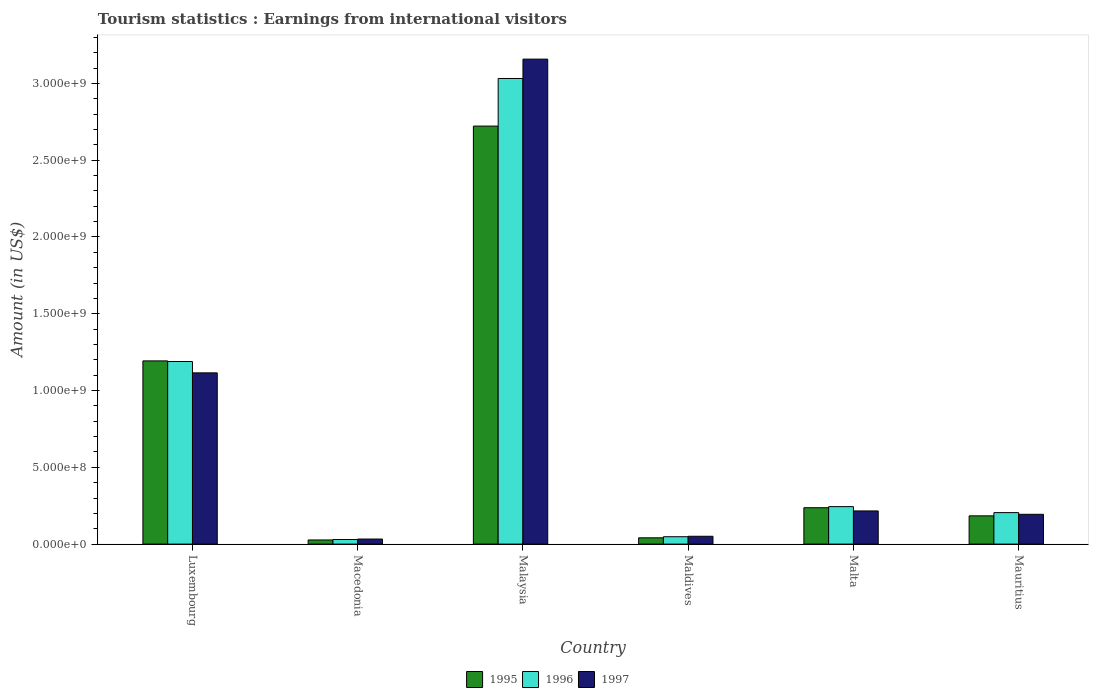How many different coloured bars are there?
Keep it short and to the point. 3. Are the number of bars on each tick of the X-axis equal?
Your response must be concise. Yes. What is the label of the 6th group of bars from the left?
Provide a succinct answer. Mauritius. In how many cases, is the number of bars for a given country not equal to the number of legend labels?
Your response must be concise. 0. What is the earnings from international visitors in 1995 in Malaysia?
Give a very brief answer. 2.72e+09. Across all countries, what is the maximum earnings from international visitors in 1996?
Provide a succinct answer. 3.03e+09. Across all countries, what is the minimum earnings from international visitors in 1995?
Your answer should be very brief. 2.70e+07. In which country was the earnings from international visitors in 1997 maximum?
Your answer should be very brief. Malaysia. In which country was the earnings from international visitors in 1995 minimum?
Provide a succinct answer. Macedonia. What is the total earnings from international visitors in 1995 in the graph?
Provide a succinct answer. 4.40e+09. What is the difference between the earnings from international visitors in 1995 in Macedonia and that in Mauritius?
Your answer should be very brief. -1.57e+08. What is the difference between the earnings from international visitors in 1995 in Luxembourg and the earnings from international visitors in 1997 in Malta?
Your response must be concise. 9.77e+08. What is the average earnings from international visitors in 1997 per country?
Keep it short and to the point. 7.94e+08. What is the difference between the earnings from international visitors of/in 1996 and earnings from international visitors of/in 1997 in Luxembourg?
Provide a succinct answer. 7.40e+07. In how many countries, is the earnings from international visitors in 1997 greater than 1400000000 US$?
Give a very brief answer. 1. What is the ratio of the earnings from international visitors in 1996 in Malaysia to that in Mauritius?
Make the answer very short. 14.79. Is the difference between the earnings from international visitors in 1996 in Luxembourg and Mauritius greater than the difference between the earnings from international visitors in 1997 in Luxembourg and Mauritius?
Offer a very short reply. Yes. What is the difference between the highest and the second highest earnings from international visitors in 1996?
Make the answer very short. 2.79e+09. What is the difference between the highest and the lowest earnings from international visitors in 1997?
Your answer should be compact. 3.12e+09. Is the sum of the earnings from international visitors in 1996 in Macedonia and Maldives greater than the maximum earnings from international visitors in 1995 across all countries?
Provide a short and direct response. No. What does the 3rd bar from the left in Malta represents?
Offer a very short reply. 1997. Are all the bars in the graph horizontal?
Provide a succinct answer. No. Are the values on the major ticks of Y-axis written in scientific E-notation?
Your answer should be compact. Yes. Does the graph contain any zero values?
Provide a succinct answer. No. What is the title of the graph?
Your answer should be very brief. Tourism statistics : Earnings from international visitors. What is the Amount (in US$) of 1995 in Luxembourg?
Ensure brevity in your answer.  1.19e+09. What is the Amount (in US$) of 1996 in Luxembourg?
Offer a very short reply. 1.19e+09. What is the Amount (in US$) in 1997 in Luxembourg?
Provide a short and direct response. 1.12e+09. What is the Amount (in US$) in 1995 in Macedonia?
Keep it short and to the point. 2.70e+07. What is the Amount (in US$) in 1996 in Macedonia?
Provide a short and direct response. 3.00e+07. What is the Amount (in US$) of 1997 in Macedonia?
Give a very brief answer. 3.30e+07. What is the Amount (in US$) in 1995 in Malaysia?
Offer a terse response. 2.72e+09. What is the Amount (in US$) of 1996 in Malaysia?
Provide a short and direct response. 3.03e+09. What is the Amount (in US$) in 1997 in Malaysia?
Ensure brevity in your answer.  3.16e+09. What is the Amount (in US$) in 1995 in Maldives?
Provide a short and direct response. 4.10e+07. What is the Amount (in US$) in 1996 in Maldives?
Your response must be concise. 4.80e+07. What is the Amount (in US$) of 1997 in Maldives?
Keep it short and to the point. 5.10e+07. What is the Amount (in US$) of 1995 in Malta?
Provide a succinct answer. 2.37e+08. What is the Amount (in US$) in 1996 in Malta?
Your answer should be compact. 2.44e+08. What is the Amount (in US$) of 1997 in Malta?
Ensure brevity in your answer.  2.16e+08. What is the Amount (in US$) of 1995 in Mauritius?
Ensure brevity in your answer.  1.84e+08. What is the Amount (in US$) in 1996 in Mauritius?
Ensure brevity in your answer.  2.05e+08. What is the Amount (in US$) in 1997 in Mauritius?
Offer a very short reply. 1.94e+08. Across all countries, what is the maximum Amount (in US$) in 1995?
Provide a succinct answer. 2.72e+09. Across all countries, what is the maximum Amount (in US$) in 1996?
Provide a succinct answer. 3.03e+09. Across all countries, what is the maximum Amount (in US$) of 1997?
Your answer should be very brief. 3.16e+09. Across all countries, what is the minimum Amount (in US$) of 1995?
Offer a very short reply. 2.70e+07. Across all countries, what is the minimum Amount (in US$) of 1996?
Offer a very short reply. 3.00e+07. Across all countries, what is the minimum Amount (in US$) of 1997?
Offer a very short reply. 3.30e+07. What is the total Amount (in US$) in 1995 in the graph?
Your answer should be very brief. 4.40e+09. What is the total Amount (in US$) in 1996 in the graph?
Offer a very short reply. 4.75e+09. What is the total Amount (in US$) in 1997 in the graph?
Your answer should be very brief. 4.77e+09. What is the difference between the Amount (in US$) of 1995 in Luxembourg and that in Macedonia?
Offer a very short reply. 1.17e+09. What is the difference between the Amount (in US$) of 1996 in Luxembourg and that in Macedonia?
Provide a short and direct response. 1.16e+09. What is the difference between the Amount (in US$) of 1997 in Luxembourg and that in Macedonia?
Give a very brief answer. 1.08e+09. What is the difference between the Amount (in US$) in 1995 in Luxembourg and that in Malaysia?
Provide a succinct answer. -1.53e+09. What is the difference between the Amount (in US$) of 1996 in Luxembourg and that in Malaysia?
Offer a terse response. -1.84e+09. What is the difference between the Amount (in US$) of 1997 in Luxembourg and that in Malaysia?
Your answer should be very brief. -2.04e+09. What is the difference between the Amount (in US$) of 1995 in Luxembourg and that in Maldives?
Keep it short and to the point. 1.15e+09. What is the difference between the Amount (in US$) of 1996 in Luxembourg and that in Maldives?
Keep it short and to the point. 1.14e+09. What is the difference between the Amount (in US$) in 1997 in Luxembourg and that in Maldives?
Make the answer very short. 1.06e+09. What is the difference between the Amount (in US$) in 1995 in Luxembourg and that in Malta?
Offer a very short reply. 9.56e+08. What is the difference between the Amount (in US$) of 1996 in Luxembourg and that in Malta?
Keep it short and to the point. 9.45e+08. What is the difference between the Amount (in US$) of 1997 in Luxembourg and that in Malta?
Your answer should be compact. 8.99e+08. What is the difference between the Amount (in US$) of 1995 in Luxembourg and that in Mauritius?
Your answer should be compact. 1.01e+09. What is the difference between the Amount (in US$) in 1996 in Luxembourg and that in Mauritius?
Provide a short and direct response. 9.84e+08. What is the difference between the Amount (in US$) in 1997 in Luxembourg and that in Mauritius?
Your response must be concise. 9.21e+08. What is the difference between the Amount (in US$) of 1995 in Macedonia and that in Malaysia?
Provide a succinct answer. -2.70e+09. What is the difference between the Amount (in US$) of 1996 in Macedonia and that in Malaysia?
Ensure brevity in your answer.  -3.00e+09. What is the difference between the Amount (in US$) in 1997 in Macedonia and that in Malaysia?
Keep it short and to the point. -3.12e+09. What is the difference between the Amount (in US$) of 1995 in Macedonia and that in Maldives?
Provide a short and direct response. -1.40e+07. What is the difference between the Amount (in US$) of 1996 in Macedonia and that in Maldives?
Provide a short and direct response. -1.80e+07. What is the difference between the Amount (in US$) in 1997 in Macedonia and that in Maldives?
Your answer should be compact. -1.80e+07. What is the difference between the Amount (in US$) of 1995 in Macedonia and that in Malta?
Your response must be concise. -2.10e+08. What is the difference between the Amount (in US$) in 1996 in Macedonia and that in Malta?
Your answer should be compact. -2.14e+08. What is the difference between the Amount (in US$) of 1997 in Macedonia and that in Malta?
Give a very brief answer. -1.83e+08. What is the difference between the Amount (in US$) of 1995 in Macedonia and that in Mauritius?
Make the answer very short. -1.57e+08. What is the difference between the Amount (in US$) in 1996 in Macedonia and that in Mauritius?
Your answer should be very brief. -1.75e+08. What is the difference between the Amount (in US$) in 1997 in Macedonia and that in Mauritius?
Your response must be concise. -1.61e+08. What is the difference between the Amount (in US$) of 1995 in Malaysia and that in Maldives?
Keep it short and to the point. 2.68e+09. What is the difference between the Amount (in US$) in 1996 in Malaysia and that in Maldives?
Offer a very short reply. 2.98e+09. What is the difference between the Amount (in US$) of 1997 in Malaysia and that in Maldives?
Give a very brief answer. 3.11e+09. What is the difference between the Amount (in US$) of 1995 in Malaysia and that in Malta?
Provide a short and direct response. 2.48e+09. What is the difference between the Amount (in US$) in 1996 in Malaysia and that in Malta?
Give a very brief answer. 2.79e+09. What is the difference between the Amount (in US$) in 1997 in Malaysia and that in Malta?
Provide a succinct answer. 2.94e+09. What is the difference between the Amount (in US$) in 1995 in Malaysia and that in Mauritius?
Your response must be concise. 2.54e+09. What is the difference between the Amount (in US$) in 1996 in Malaysia and that in Mauritius?
Offer a very short reply. 2.83e+09. What is the difference between the Amount (in US$) of 1997 in Malaysia and that in Mauritius?
Your response must be concise. 2.96e+09. What is the difference between the Amount (in US$) in 1995 in Maldives and that in Malta?
Your answer should be very brief. -1.96e+08. What is the difference between the Amount (in US$) of 1996 in Maldives and that in Malta?
Provide a succinct answer. -1.96e+08. What is the difference between the Amount (in US$) of 1997 in Maldives and that in Malta?
Make the answer very short. -1.65e+08. What is the difference between the Amount (in US$) of 1995 in Maldives and that in Mauritius?
Give a very brief answer. -1.43e+08. What is the difference between the Amount (in US$) in 1996 in Maldives and that in Mauritius?
Offer a very short reply. -1.57e+08. What is the difference between the Amount (in US$) in 1997 in Maldives and that in Mauritius?
Provide a short and direct response. -1.43e+08. What is the difference between the Amount (in US$) of 1995 in Malta and that in Mauritius?
Ensure brevity in your answer.  5.30e+07. What is the difference between the Amount (in US$) in 1996 in Malta and that in Mauritius?
Offer a terse response. 3.90e+07. What is the difference between the Amount (in US$) in 1997 in Malta and that in Mauritius?
Provide a short and direct response. 2.20e+07. What is the difference between the Amount (in US$) in 1995 in Luxembourg and the Amount (in US$) in 1996 in Macedonia?
Provide a short and direct response. 1.16e+09. What is the difference between the Amount (in US$) of 1995 in Luxembourg and the Amount (in US$) of 1997 in Macedonia?
Ensure brevity in your answer.  1.16e+09. What is the difference between the Amount (in US$) in 1996 in Luxembourg and the Amount (in US$) in 1997 in Macedonia?
Offer a terse response. 1.16e+09. What is the difference between the Amount (in US$) of 1995 in Luxembourg and the Amount (in US$) of 1996 in Malaysia?
Provide a succinct answer. -1.84e+09. What is the difference between the Amount (in US$) in 1995 in Luxembourg and the Amount (in US$) in 1997 in Malaysia?
Offer a very short reply. -1.96e+09. What is the difference between the Amount (in US$) in 1996 in Luxembourg and the Amount (in US$) in 1997 in Malaysia?
Give a very brief answer. -1.97e+09. What is the difference between the Amount (in US$) in 1995 in Luxembourg and the Amount (in US$) in 1996 in Maldives?
Your answer should be compact. 1.14e+09. What is the difference between the Amount (in US$) in 1995 in Luxembourg and the Amount (in US$) in 1997 in Maldives?
Your answer should be very brief. 1.14e+09. What is the difference between the Amount (in US$) of 1996 in Luxembourg and the Amount (in US$) of 1997 in Maldives?
Your response must be concise. 1.14e+09. What is the difference between the Amount (in US$) in 1995 in Luxembourg and the Amount (in US$) in 1996 in Malta?
Your answer should be very brief. 9.49e+08. What is the difference between the Amount (in US$) of 1995 in Luxembourg and the Amount (in US$) of 1997 in Malta?
Provide a succinct answer. 9.77e+08. What is the difference between the Amount (in US$) in 1996 in Luxembourg and the Amount (in US$) in 1997 in Malta?
Your answer should be very brief. 9.73e+08. What is the difference between the Amount (in US$) of 1995 in Luxembourg and the Amount (in US$) of 1996 in Mauritius?
Keep it short and to the point. 9.88e+08. What is the difference between the Amount (in US$) in 1995 in Luxembourg and the Amount (in US$) in 1997 in Mauritius?
Your answer should be very brief. 9.99e+08. What is the difference between the Amount (in US$) of 1996 in Luxembourg and the Amount (in US$) of 1997 in Mauritius?
Keep it short and to the point. 9.95e+08. What is the difference between the Amount (in US$) of 1995 in Macedonia and the Amount (in US$) of 1996 in Malaysia?
Provide a succinct answer. -3.00e+09. What is the difference between the Amount (in US$) of 1995 in Macedonia and the Amount (in US$) of 1997 in Malaysia?
Give a very brief answer. -3.13e+09. What is the difference between the Amount (in US$) in 1996 in Macedonia and the Amount (in US$) in 1997 in Malaysia?
Keep it short and to the point. -3.13e+09. What is the difference between the Amount (in US$) of 1995 in Macedonia and the Amount (in US$) of 1996 in Maldives?
Offer a very short reply. -2.10e+07. What is the difference between the Amount (in US$) in 1995 in Macedonia and the Amount (in US$) in 1997 in Maldives?
Give a very brief answer. -2.40e+07. What is the difference between the Amount (in US$) of 1996 in Macedonia and the Amount (in US$) of 1997 in Maldives?
Make the answer very short. -2.10e+07. What is the difference between the Amount (in US$) of 1995 in Macedonia and the Amount (in US$) of 1996 in Malta?
Offer a terse response. -2.17e+08. What is the difference between the Amount (in US$) of 1995 in Macedonia and the Amount (in US$) of 1997 in Malta?
Your response must be concise. -1.89e+08. What is the difference between the Amount (in US$) in 1996 in Macedonia and the Amount (in US$) in 1997 in Malta?
Offer a very short reply. -1.86e+08. What is the difference between the Amount (in US$) in 1995 in Macedonia and the Amount (in US$) in 1996 in Mauritius?
Offer a terse response. -1.78e+08. What is the difference between the Amount (in US$) in 1995 in Macedonia and the Amount (in US$) in 1997 in Mauritius?
Offer a very short reply. -1.67e+08. What is the difference between the Amount (in US$) in 1996 in Macedonia and the Amount (in US$) in 1997 in Mauritius?
Give a very brief answer. -1.64e+08. What is the difference between the Amount (in US$) of 1995 in Malaysia and the Amount (in US$) of 1996 in Maldives?
Make the answer very short. 2.67e+09. What is the difference between the Amount (in US$) in 1995 in Malaysia and the Amount (in US$) in 1997 in Maldives?
Offer a very short reply. 2.67e+09. What is the difference between the Amount (in US$) of 1996 in Malaysia and the Amount (in US$) of 1997 in Maldives?
Offer a terse response. 2.98e+09. What is the difference between the Amount (in US$) of 1995 in Malaysia and the Amount (in US$) of 1996 in Malta?
Offer a terse response. 2.48e+09. What is the difference between the Amount (in US$) of 1995 in Malaysia and the Amount (in US$) of 1997 in Malta?
Ensure brevity in your answer.  2.51e+09. What is the difference between the Amount (in US$) of 1996 in Malaysia and the Amount (in US$) of 1997 in Malta?
Your answer should be compact. 2.82e+09. What is the difference between the Amount (in US$) in 1995 in Malaysia and the Amount (in US$) in 1996 in Mauritius?
Give a very brief answer. 2.52e+09. What is the difference between the Amount (in US$) in 1995 in Malaysia and the Amount (in US$) in 1997 in Mauritius?
Provide a succinct answer. 2.53e+09. What is the difference between the Amount (in US$) of 1996 in Malaysia and the Amount (in US$) of 1997 in Mauritius?
Make the answer very short. 2.84e+09. What is the difference between the Amount (in US$) of 1995 in Maldives and the Amount (in US$) of 1996 in Malta?
Make the answer very short. -2.03e+08. What is the difference between the Amount (in US$) in 1995 in Maldives and the Amount (in US$) in 1997 in Malta?
Give a very brief answer. -1.75e+08. What is the difference between the Amount (in US$) in 1996 in Maldives and the Amount (in US$) in 1997 in Malta?
Provide a succinct answer. -1.68e+08. What is the difference between the Amount (in US$) of 1995 in Maldives and the Amount (in US$) of 1996 in Mauritius?
Provide a short and direct response. -1.64e+08. What is the difference between the Amount (in US$) in 1995 in Maldives and the Amount (in US$) in 1997 in Mauritius?
Offer a very short reply. -1.53e+08. What is the difference between the Amount (in US$) in 1996 in Maldives and the Amount (in US$) in 1997 in Mauritius?
Your response must be concise. -1.46e+08. What is the difference between the Amount (in US$) in 1995 in Malta and the Amount (in US$) in 1996 in Mauritius?
Your answer should be very brief. 3.20e+07. What is the difference between the Amount (in US$) of 1995 in Malta and the Amount (in US$) of 1997 in Mauritius?
Offer a terse response. 4.30e+07. What is the average Amount (in US$) in 1995 per country?
Make the answer very short. 7.34e+08. What is the average Amount (in US$) of 1996 per country?
Your response must be concise. 7.91e+08. What is the average Amount (in US$) of 1997 per country?
Give a very brief answer. 7.94e+08. What is the difference between the Amount (in US$) in 1995 and Amount (in US$) in 1996 in Luxembourg?
Offer a very short reply. 4.00e+06. What is the difference between the Amount (in US$) in 1995 and Amount (in US$) in 1997 in Luxembourg?
Give a very brief answer. 7.80e+07. What is the difference between the Amount (in US$) in 1996 and Amount (in US$) in 1997 in Luxembourg?
Your answer should be very brief. 7.40e+07. What is the difference between the Amount (in US$) of 1995 and Amount (in US$) of 1997 in Macedonia?
Offer a very short reply. -6.00e+06. What is the difference between the Amount (in US$) of 1996 and Amount (in US$) of 1997 in Macedonia?
Your answer should be compact. -3.00e+06. What is the difference between the Amount (in US$) of 1995 and Amount (in US$) of 1996 in Malaysia?
Offer a very short reply. -3.10e+08. What is the difference between the Amount (in US$) in 1995 and Amount (in US$) in 1997 in Malaysia?
Offer a terse response. -4.36e+08. What is the difference between the Amount (in US$) in 1996 and Amount (in US$) in 1997 in Malaysia?
Offer a terse response. -1.26e+08. What is the difference between the Amount (in US$) in 1995 and Amount (in US$) in 1996 in Maldives?
Offer a terse response. -7.00e+06. What is the difference between the Amount (in US$) of 1995 and Amount (in US$) of 1997 in Maldives?
Offer a very short reply. -1.00e+07. What is the difference between the Amount (in US$) in 1996 and Amount (in US$) in 1997 in Maldives?
Give a very brief answer. -3.00e+06. What is the difference between the Amount (in US$) in 1995 and Amount (in US$) in 1996 in Malta?
Offer a terse response. -7.00e+06. What is the difference between the Amount (in US$) of 1995 and Amount (in US$) of 1997 in Malta?
Your response must be concise. 2.10e+07. What is the difference between the Amount (in US$) of 1996 and Amount (in US$) of 1997 in Malta?
Make the answer very short. 2.80e+07. What is the difference between the Amount (in US$) of 1995 and Amount (in US$) of 1996 in Mauritius?
Ensure brevity in your answer.  -2.10e+07. What is the difference between the Amount (in US$) in 1995 and Amount (in US$) in 1997 in Mauritius?
Offer a very short reply. -1.00e+07. What is the difference between the Amount (in US$) of 1996 and Amount (in US$) of 1997 in Mauritius?
Offer a very short reply. 1.10e+07. What is the ratio of the Amount (in US$) in 1995 in Luxembourg to that in Macedonia?
Provide a short and direct response. 44.19. What is the ratio of the Amount (in US$) of 1996 in Luxembourg to that in Macedonia?
Give a very brief answer. 39.63. What is the ratio of the Amount (in US$) in 1997 in Luxembourg to that in Macedonia?
Your answer should be compact. 33.79. What is the ratio of the Amount (in US$) in 1995 in Luxembourg to that in Malaysia?
Provide a succinct answer. 0.44. What is the ratio of the Amount (in US$) in 1996 in Luxembourg to that in Malaysia?
Offer a terse response. 0.39. What is the ratio of the Amount (in US$) of 1997 in Luxembourg to that in Malaysia?
Ensure brevity in your answer.  0.35. What is the ratio of the Amount (in US$) of 1995 in Luxembourg to that in Maldives?
Ensure brevity in your answer.  29.1. What is the ratio of the Amount (in US$) of 1996 in Luxembourg to that in Maldives?
Offer a terse response. 24.77. What is the ratio of the Amount (in US$) of 1997 in Luxembourg to that in Maldives?
Make the answer very short. 21.86. What is the ratio of the Amount (in US$) of 1995 in Luxembourg to that in Malta?
Keep it short and to the point. 5.03. What is the ratio of the Amount (in US$) in 1996 in Luxembourg to that in Malta?
Offer a very short reply. 4.87. What is the ratio of the Amount (in US$) of 1997 in Luxembourg to that in Malta?
Offer a very short reply. 5.16. What is the ratio of the Amount (in US$) of 1995 in Luxembourg to that in Mauritius?
Your answer should be very brief. 6.48. What is the ratio of the Amount (in US$) in 1997 in Luxembourg to that in Mauritius?
Give a very brief answer. 5.75. What is the ratio of the Amount (in US$) in 1995 in Macedonia to that in Malaysia?
Ensure brevity in your answer.  0.01. What is the ratio of the Amount (in US$) of 1996 in Macedonia to that in Malaysia?
Keep it short and to the point. 0.01. What is the ratio of the Amount (in US$) in 1997 in Macedonia to that in Malaysia?
Provide a short and direct response. 0.01. What is the ratio of the Amount (in US$) of 1995 in Macedonia to that in Maldives?
Your answer should be very brief. 0.66. What is the ratio of the Amount (in US$) of 1996 in Macedonia to that in Maldives?
Your answer should be compact. 0.62. What is the ratio of the Amount (in US$) in 1997 in Macedonia to that in Maldives?
Offer a very short reply. 0.65. What is the ratio of the Amount (in US$) of 1995 in Macedonia to that in Malta?
Give a very brief answer. 0.11. What is the ratio of the Amount (in US$) in 1996 in Macedonia to that in Malta?
Provide a succinct answer. 0.12. What is the ratio of the Amount (in US$) in 1997 in Macedonia to that in Malta?
Keep it short and to the point. 0.15. What is the ratio of the Amount (in US$) in 1995 in Macedonia to that in Mauritius?
Ensure brevity in your answer.  0.15. What is the ratio of the Amount (in US$) of 1996 in Macedonia to that in Mauritius?
Your answer should be compact. 0.15. What is the ratio of the Amount (in US$) in 1997 in Macedonia to that in Mauritius?
Provide a succinct answer. 0.17. What is the ratio of the Amount (in US$) of 1995 in Malaysia to that in Maldives?
Offer a very short reply. 66.39. What is the ratio of the Amount (in US$) in 1996 in Malaysia to that in Maldives?
Make the answer very short. 63.17. What is the ratio of the Amount (in US$) in 1997 in Malaysia to that in Maldives?
Keep it short and to the point. 61.92. What is the ratio of the Amount (in US$) in 1995 in Malaysia to that in Malta?
Offer a very short reply. 11.49. What is the ratio of the Amount (in US$) of 1996 in Malaysia to that in Malta?
Provide a succinct answer. 12.43. What is the ratio of the Amount (in US$) of 1997 in Malaysia to that in Malta?
Ensure brevity in your answer.  14.62. What is the ratio of the Amount (in US$) of 1995 in Malaysia to that in Mauritius?
Ensure brevity in your answer.  14.79. What is the ratio of the Amount (in US$) in 1996 in Malaysia to that in Mauritius?
Keep it short and to the point. 14.79. What is the ratio of the Amount (in US$) in 1997 in Malaysia to that in Mauritius?
Your answer should be very brief. 16.28. What is the ratio of the Amount (in US$) of 1995 in Maldives to that in Malta?
Provide a short and direct response. 0.17. What is the ratio of the Amount (in US$) of 1996 in Maldives to that in Malta?
Give a very brief answer. 0.2. What is the ratio of the Amount (in US$) of 1997 in Maldives to that in Malta?
Offer a very short reply. 0.24. What is the ratio of the Amount (in US$) of 1995 in Maldives to that in Mauritius?
Offer a very short reply. 0.22. What is the ratio of the Amount (in US$) in 1996 in Maldives to that in Mauritius?
Your answer should be compact. 0.23. What is the ratio of the Amount (in US$) in 1997 in Maldives to that in Mauritius?
Offer a terse response. 0.26. What is the ratio of the Amount (in US$) of 1995 in Malta to that in Mauritius?
Your response must be concise. 1.29. What is the ratio of the Amount (in US$) of 1996 in Malta to that in Mauritius?
Your response must be concise. 1.19. What is the ratio of the Amount (in US$) in 1997 in Malta to that in Mauritius?
Give a very brief answer. 1.11. What is the difference between the highest and the second highest Amount (in US$) in 1995?
Provide a short and direct response. 1.53e+09. What is the difference between the highest and the second highest Amount (in US$) of 1996?
Provide a succinct answer. 1.84e+09. What is the difference between the highest and the second highest Amount (in US$) of 1997?
Offer a very short reply. 2.04e+09. What is the difference between the highest and the lowest Amount (in US$) in 1995?
Offer a terse response. 2.70e+09. What is the difference between the highest and the lowest Amount (in US$) in 1996?
Provide a short and direct response. 3.00e+09. What is the difference between the highest and the lowest Amount (in US$) in 1997?
Offer a terse response. 3.12e+09. 